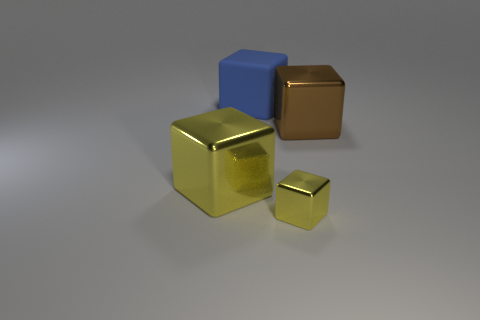Is there anything else that is made of the same material as the large blue object?
Give a very brief answer. No. What size is the brown cube that is to the right of the large object that is behind the big shiny block that is behind the large yellow cube?
Give a very brief answer. Large. The metallic thing that is both on the right side of the big yellow shiny object and in front of the large brown thing has what shape?
Ensure brevity in your answer.  Cube. Is the number of cubes right of the big yellow thing the same as the number of small yellow objects on the right side of the small block?
Offer a terse response. No. Is there a big yellow cube that has the same material as the brown cube?
Make the answer very short. Yes. Is the material of the block that is right of the small yellow block the same as the small yellow block?
Make the answer very short. Yes. What size is the block that is both in front of the big brown metallic cube and left of the tiny block?
Give a very brief answer. Large. What color is the rubber thing?
Make the answer very short. Blue. What number of tiny yellow things are there?
Ensure brevity in your answer.  1. How many other small objects are the same color as the rubber object?
Provide a succinct answer. 0. 